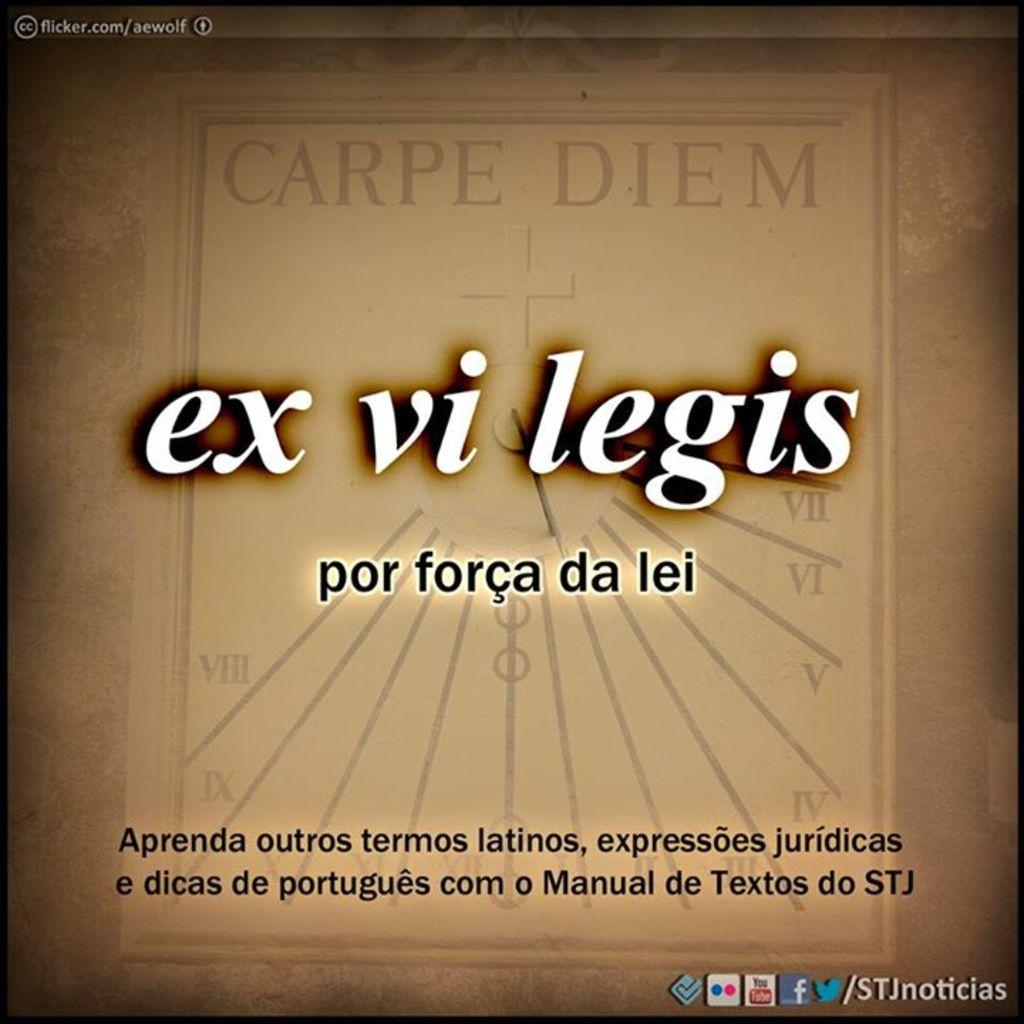<image>
Render a clear and concise summary of the photo. A poster with ex vi legis written in the middle under the words Carpe Diem. 